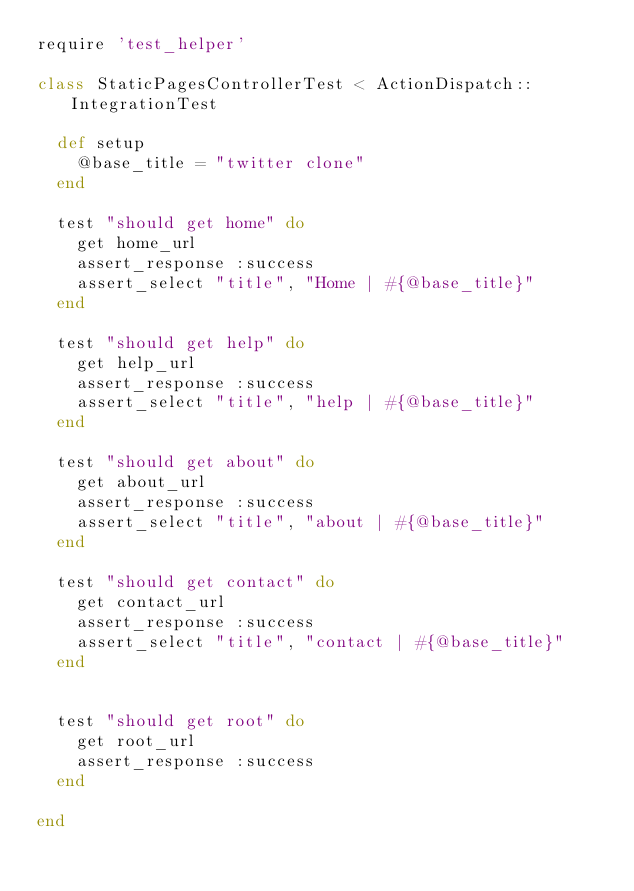<code> <loc_0><loc_0><loc_500><loc_500><_Ruby_>require 'test_helper'

class StaticPagesControllerTest < ActionDispatch::IntegrationTest

  def setup
    @base_title = "twitter clone"
  end

  test "should get home" do
    get home_url
    assert_response :success
    assert_select "title", "Home | #{@base_title}"
  end

  test "should get help" do
    get help_url
    assert_response :success
    assert_select "title", "help | #{@base_title}"
  end

  test "should get about" do
    get about_url
    assert_response :success
    assert_select "title", "about | #{@base_title}"
  end

  test "should get contact" do
    get contact_url
    assert_response :success
    assert_select "title", "contact | #{@base_title}"
  end


  test "should get root" do
    get root_url
    assert_response :success
  end

end
</code> 